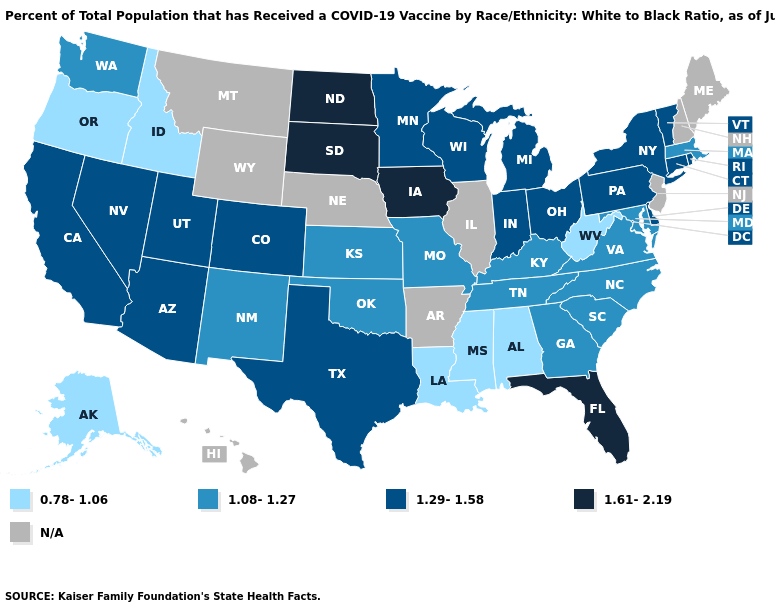Among the states that border California , does Arizona have the lowest value?
Give a very brief answer. No. Does Massachusetts have the highest value in the Northeast?
Write a very short answer. No. Name the states that have a value in the range 1.61-2.19?
Concise answer only. Florida, Iowa, North Dakota, South Dakota. Among the states that border Nevada , which have the highest value?
Concise answer only. Arizona, California, Utah. What is the value of Iowa?
Quick response, please. 1.61-2.19. What is the highest value in the Northeast ?
Answer briefly. 1.29-1.58. Does California have the lowest value in the USA?
Be succinct. No. Among the states that border Tennessee , which have the highest value?
Be succinct. Georgia, Kentucky, Missouri, North Carolina, Virginia. Name the states that have a value in the range 1.61-2.19?
Be succinct. Florida, Iowa, North Dakota, South Dakota. Name the states that have a value in the range 1.08-1.27?
Keep it brief. Georgia, Kansas, Kentucky, Maryland, Massachusetts, Missouri, New Mexico, North Carolina, Oklahoma, South Carolina, Tennessee, Virginia, Washington. What is the value of Maryland?
Answer briefly. 1.08-1.27. What is the lowest value in the USA?
Be succinct. 0.78-1.06. Name the states that have a value in the range 1.61-2.19?
Give a very brief answer. Florida, Iowa, North Dakota, South Dakota. What is the lowest value in the Northeast?
Quick response, please. 1.08-1.27. Is the legend a continuous bar?
Be succinct. No. 